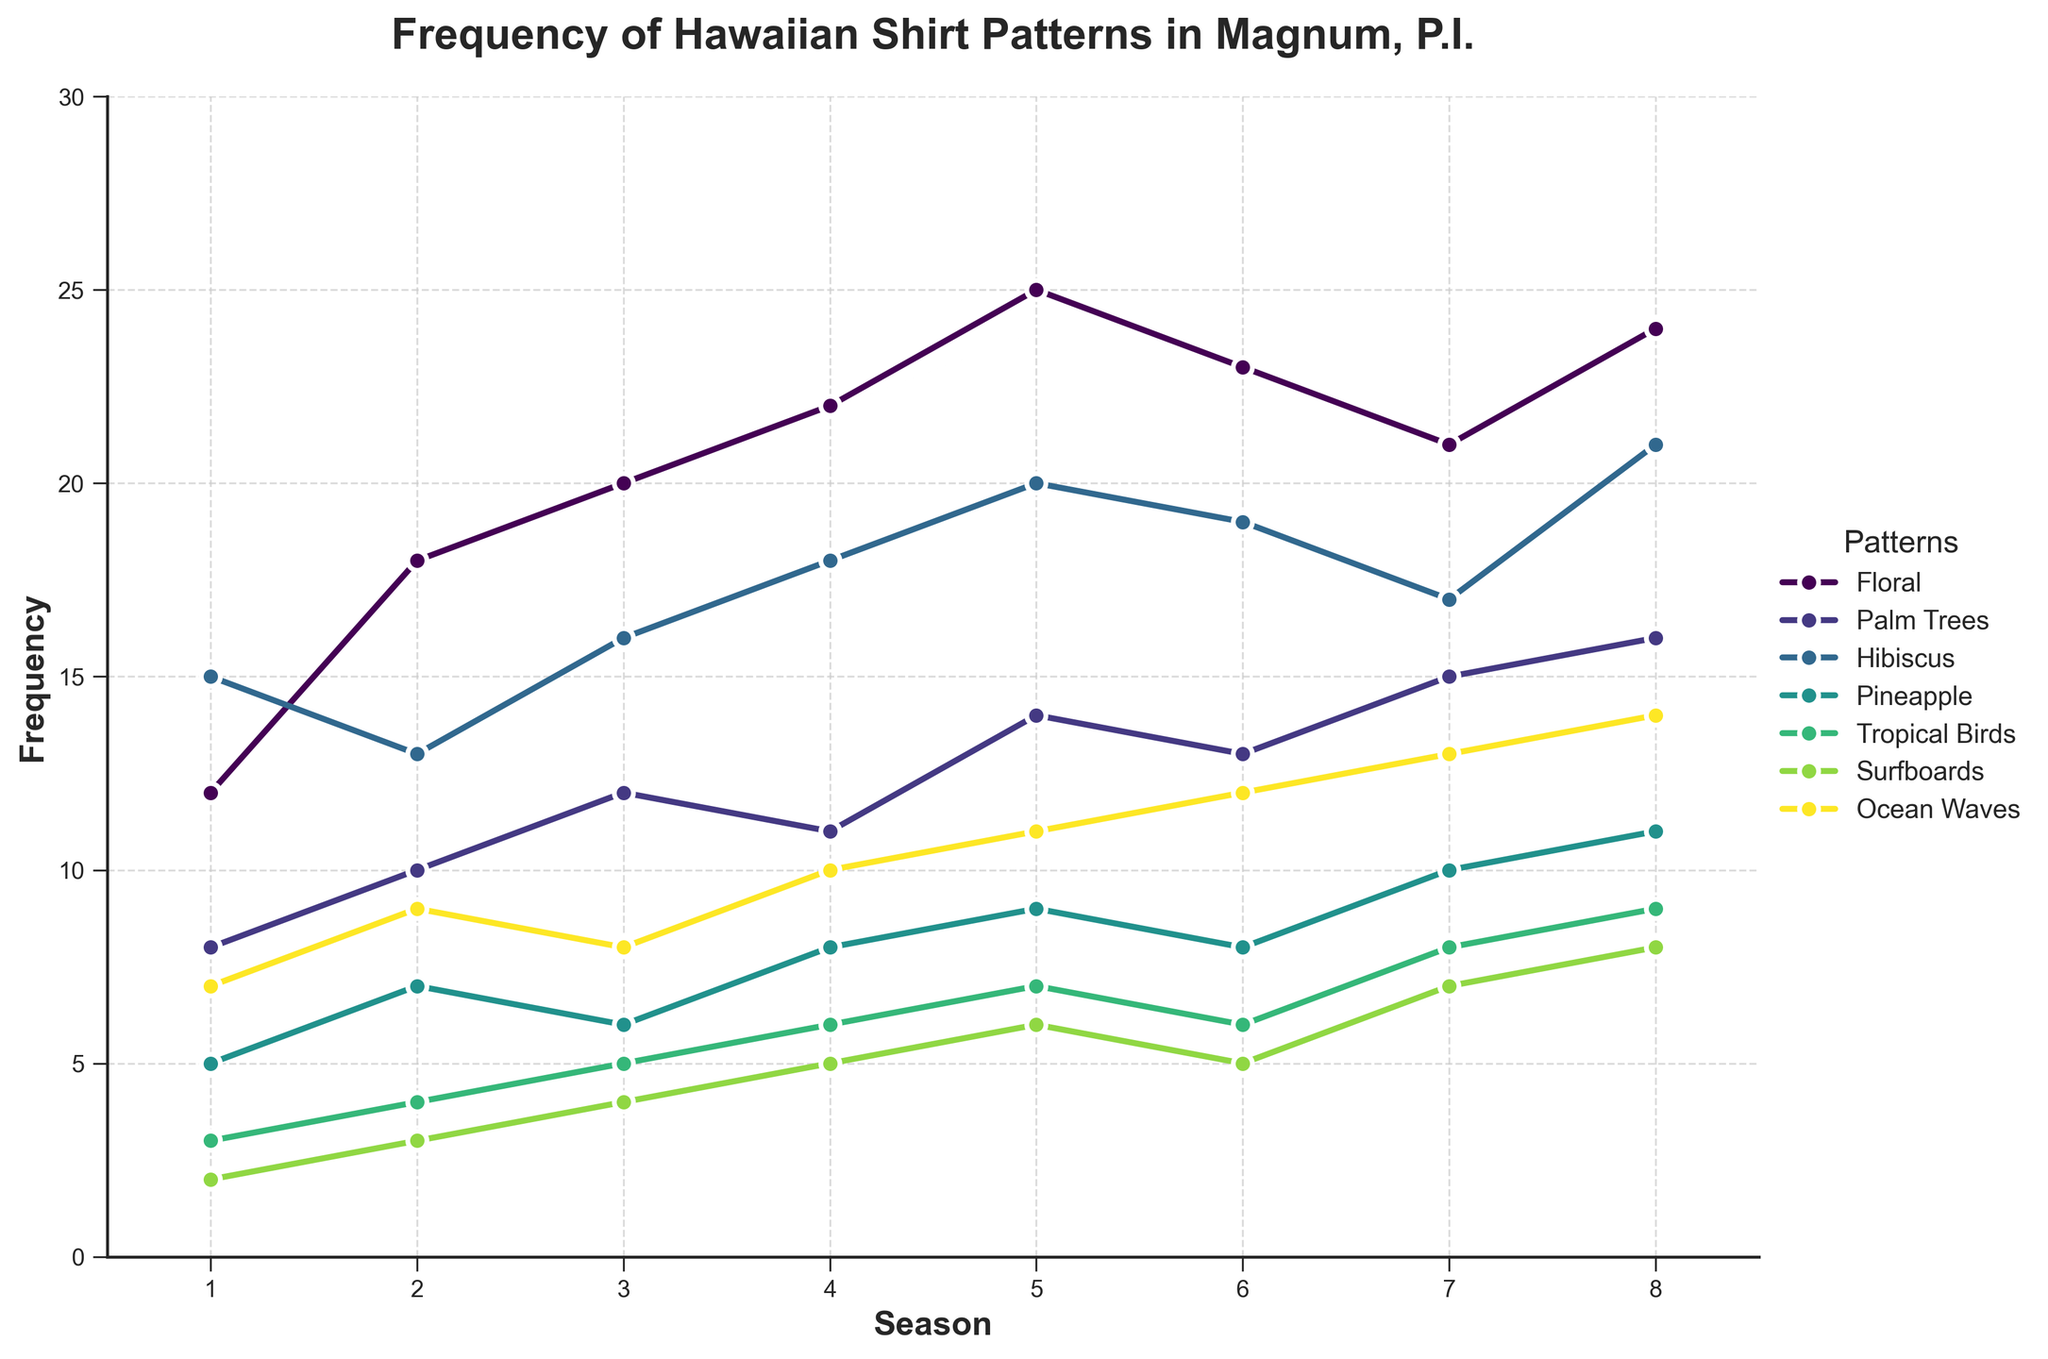What's the average number of Floral patterns worn across all seasons? To find the average, sum the values of Floral patterns for all seasons: 12 + 18 + 20 + 22 + 25 + 23 + 21 + 24 = 165. Then divide by the number of seasons, which is 8. Thus, 165/8 = 20.625
Answer: 20.625 In which season does the Tropical Birds pattern appear most frequently? Observe the line representing Tropical Birds and identify the highest point. The highest frequency for Tropical Birds is in Season 8.
Answer: Season 8 Compare the frequency of Floral and Hibiscus patterns in Season 4. Which one is higher and by how much? In Season 4, Floral frequency is 22 and Hibiscus frequency is 18. The difference is 22 - 18 = 4. Floral is higher than Hibiscus by 4.
Answer: Floral by 4 What is the trend for the frequency of Surfboards patterns from Season 1 to Season 8? Observe the line for Surfboards; it continuously increases from Season 1 (2) to Season 8 (8), showing an overall upward trend.
Answer: Upward trend How many seasons show a frequency of at least 10 for Palm Trees pattern? Identify the seasons where the Palm Trees frequency is greater than or equal to 10. These are Seasons 2, 3, 5, 7, and 8, which makes 5 seasons.
Answer: 5 seasons Which pattern consistently has the lowest frequency across all seasons? Examine the lowest points among all lines in each season. Surfboards consistently has the lowest frequency in each season.
Answer: Surfboards Calculate the total frequency of Ocean Waves patterns over all seasons. Sum the values for Ocean Waves from each season: 7 + 9 + 8 + 10 + 11 + 12 + 13 + 14 = 84.
Answer: 84 Is there any season where the number of Pineapple and Tropical Birds patterns are equal? Check each season for equal frequencies of both patterns. In Season 6, both patterns have a frequency of 8.
Answer: Season 6 Which pattern has the greatest increase in frequency from Season 7 to Season 8? Calculate the increase for each pattern between Season 7 and Season 8: 
Floral: 24 - 21 = 3
Palm Trees: 16 - 15 = 1
Hibiscus: 21 - 17 = 4
Pineapple: 11 - 10 = 1
Tropical Birds: 9 - 8 = 1
Surfboards: 8 - 7 = 1
Ocean Waves: 14 - 13 = 1
Hibiscus has the greatest increase of 4.
Answer: Hibiscus Which season shows the highest combined frequency for all patterns? Calculate the combined frequency for each season and compare:
Season 1: 12 + 8 + 15 + 5 + 3 + 2 + 7 = 52
Season 2: 18 + 10 + 13 + 7 + 4 + 3 + 9 = 64
Season 3: 20 + 12 + 16 + 6 + 5 + 4 + 8 = 71
Season 4: 22 + 11 + 18 + 8 + 6 + 5 + 10 = 80
Season 5: 25 + 14 + 20 + 9 + 7 + 6 + 11 = 92
Season 6: 23 + 13 + 19 + 8 + 6 + 5 + 12 = 86
Season 7: 21 + 15 + 17 + 10 + 8 + 7 + 13 = 91
Season 8: 24 + 16 + 21 + 11 + 9 + 8 + 14 = 103
Season 8 has the highest combined frequency of 103.
Answer: Season 8 